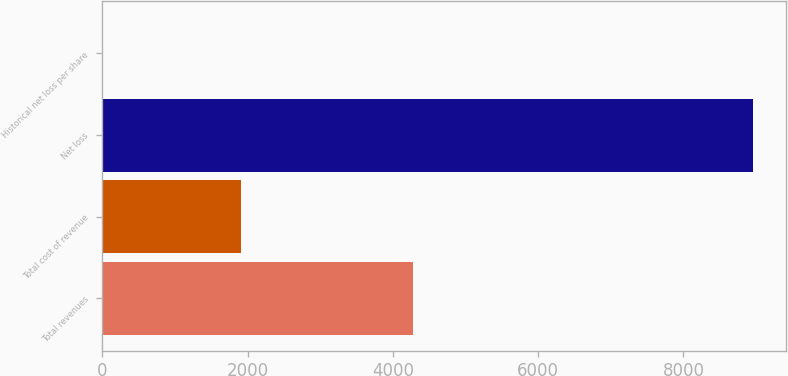Convert chart. <chart><loc_0><loc_0><loc_500><loc_500><bar_chart><fcel>Total revenues<fcel>Total cost of revenue<fcel>Net loss<fcel>Historical net loss per share<nl><fcel>4276<fcel>1910<fcel>8960<fcel>0.28<nl></chart> 